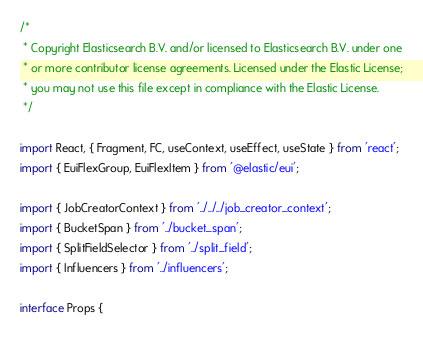Convert code to text. <code><loc_0><loc_0><loc_500><loc_500><_TypeScript_>/*
 * Copyright Elasticsearch B.V. and/or licensed to Elasticsearch B.V. under one
 * or more contributor license agreements. Licensed under the Elastic License;
 * you may not use this file except in compliance with the Elastic License.
 */

import React, { Fragment, FC, useContext, useEffect, useState } from 'react';
import { EuiFlexGroup, EuiFlexItem } from '@elastic/eui';

import { JobCreatorContext } from '../../../job_creator_context';
import { BucketSpan } from '../bucket_span';
import { SplitFieldSelector } from '../split_field';
import { Influencers } from '../influencers';

interface Props {</code> 